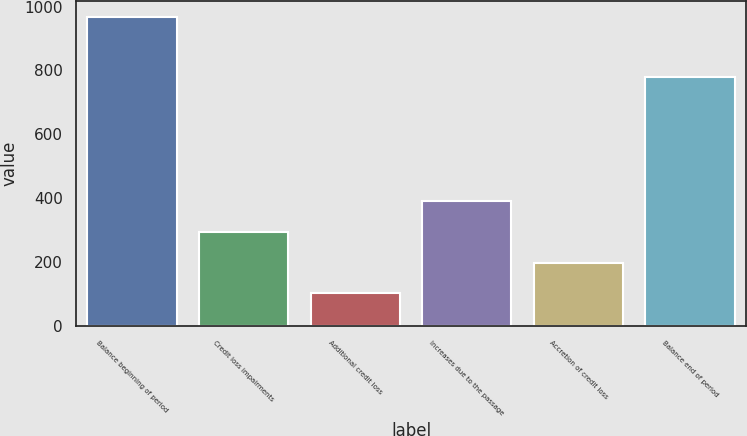Convert chart. <chart><loc_0><loc_0><loc_500><loc_500><bar_chart><fcel>Balance beginning of period<fcel>Credit loss impairments<fcel>Additional credit loss<fcel>Increases due to the passage<fcel>Accretion of credit loss<fcel>Balance end of period<nl><fcel>968<fcel>294.6<fcel>102.2<fcel>390.8<fcel>198.4<fcel>781<nl></chart> 